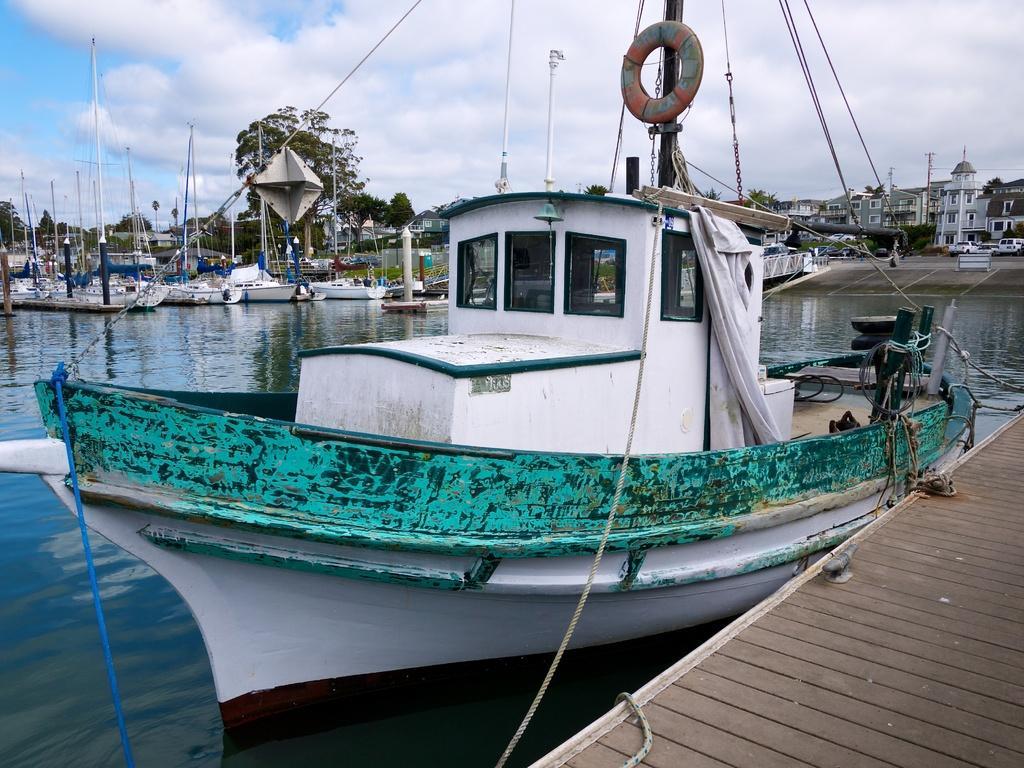How would you summarize this image in a sentence or two? In this picture we can see boats on water, vehicles on the road, buildings with windows, trees and in the background we can see the sky with clouds. 